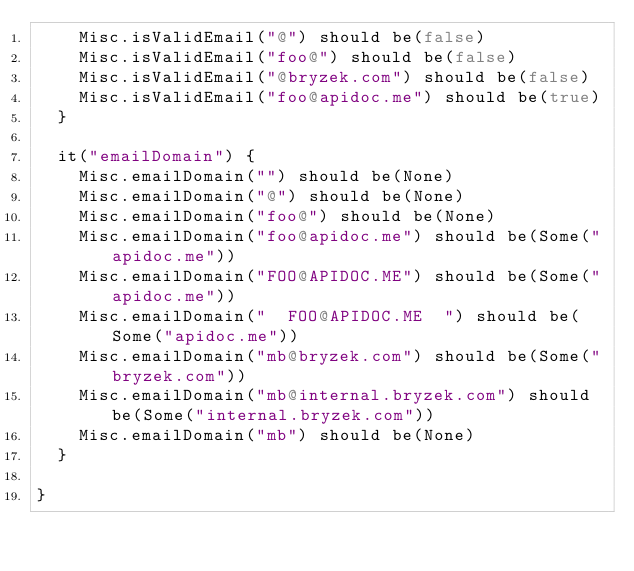Convert code to text. <code><loc_0><loc_0><loc_500><loc_500><_Scala_>    Misc.isValidEmail("@") should be(false)
    Misc.isValidEmail("foo@") should be(false)
    Misc.isValidEmail("@bryzek.com") should be(false)
    Misc.isValidEmail("foo@apidoc.me") should be(true)
  }

  it("emailDomain") {
    Misc.emailDomain("") should be(None)
    Misc.emailDomain("@") should be(None)
    Misc.emailDomain("foo@") should be(None)
    Misc.emailDomain("foo@apidoc.me") should be(Some("apidoc.me"))
    Misc.emailDomain("FOO@APIDOC.ME") should be(Some("apidoc.me"))
    Misc.emailDomain("  FOO@APIDOC.ME  ") should be(Some("apidoc.me"))
    Misc.emailDomain("mb@bryzek.com") should be(Some("bryzek.com"))
    Misc.emailDomain("mb@internal.bryzek.com") should be(Some("internal.bryzek.com"))
    Misc.emailDomain("mb") should be(None)
  }

}
</code> 